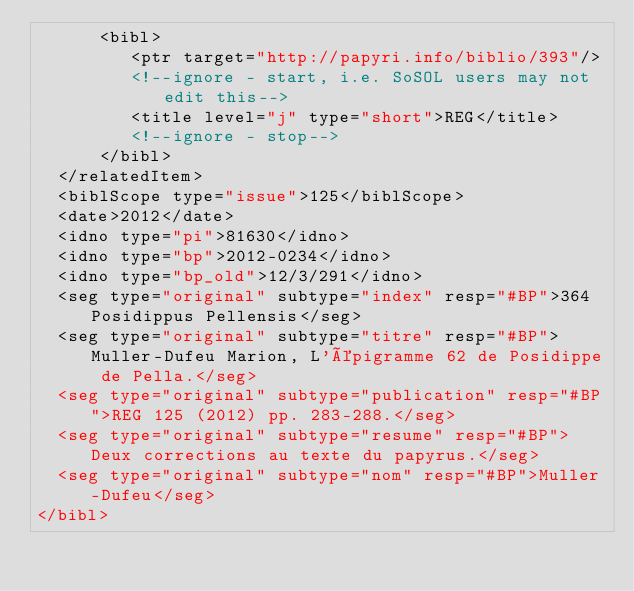<code> <loc_0><loc_0><loc_500><loc_500><_XML_>      <bibl>
         <ptr target="http://papyri.info/biblio/393"/>
         <!--ignore - start, i.e. SoSOL users may not edit this-->
         <title level="j" type="short">REG</title>
         <!--ignore - stop-->
      </bibl>
  </relatedItem>
  <biblScope type="issue">125</biblScope>
  <date>2012</date>
  <idno type="pi">81630</idno>
  <idno type="bp">2012-0234</idno>
  <idno type="bp_old">12/3/291</idno>
  <seg type="original" subtype="index" resp="#BP">364 Posidippus Pellensis</seg>
  <seg type="original" subtype="titre" resp="#BP">Muller-Dufeu Marion, L'épigramme 62 de Posidippe de Pella.</seg>
  <seg type="original" subtype="publication" resp="#BP">REG 125 (2012) pp. 283-288.</seg>
  <seg type="original" subtype="resume" resp="#BP">Deux corrections au texte du papyrus.</seg>
  <seg type="original" subtype="nom" resp="#BP">Muller-Dufeu</seg>
</bibl>
</code> 